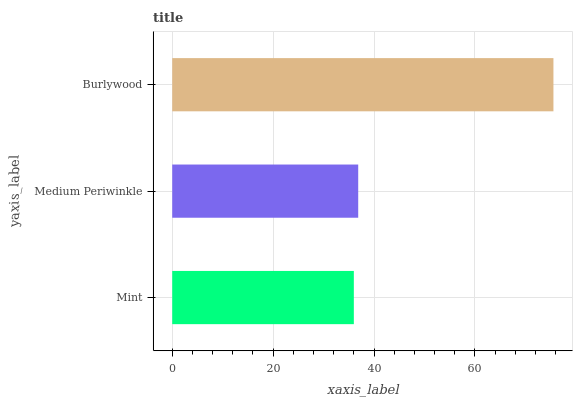Is Mint the minimum?
Answer yes or no. Yes. Is Burlywood the maximum?
Answer yes or no. Yes. Is Medium Periwinkle the minimum?
Answer yes or no. No. Is Medium Periwinkle the maximum?
Answer yes or no. No. Is Medium Periwinkle greater than Mint?
Answer yes or no. Yes. Is Mint less than Medium Periwinkle?
Answer yes or no. Yes. Is Mint greater than Medium Periwinkle?
Answer yes or no. No. Is Medium Periwinkle less than Mint?
Answer yes or no. No. Is Medium Periwinkle the high median?
Answer yes or no. Yes. Is Medium Periwinkle the low median?
Answer yes or no. Yes. Is Burlywood the high median?
Answer yes or no. No. Is Mint the low median?
Answer yes or no. No. 